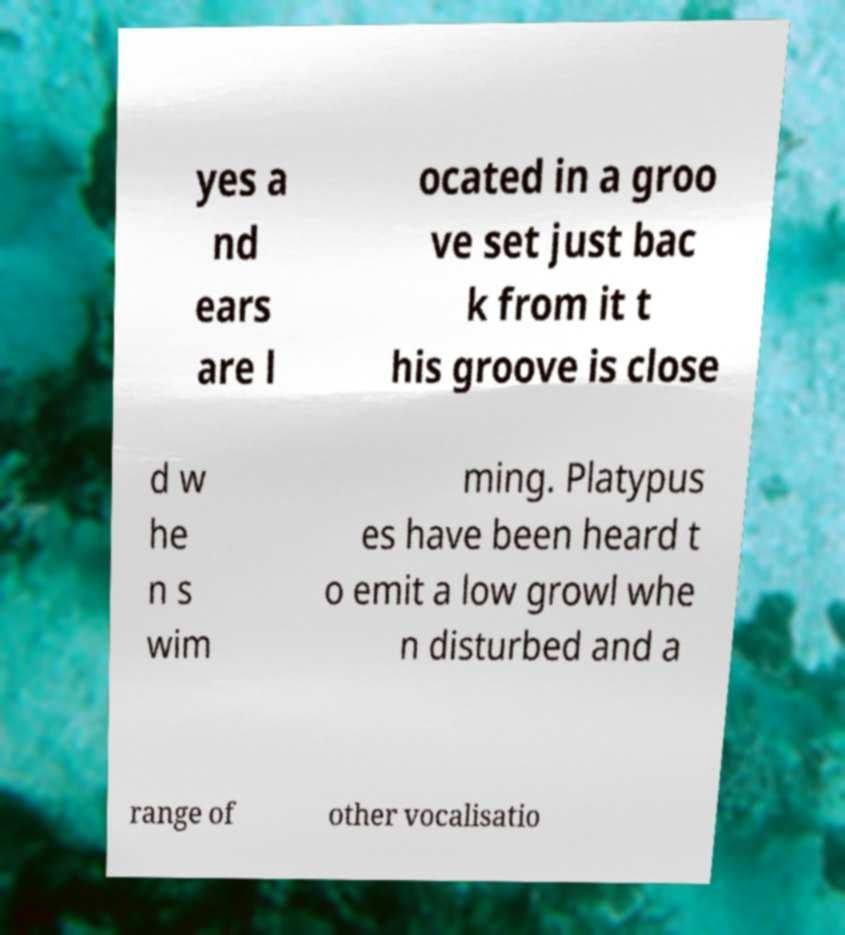There's text embedded in this image that I need extracted. Can you transcribe it verbatim? yes a nd ears are l ocated in a groo ve set just bac k from it t his groove is close d w he n s wim ming. Platypus es have been heard t o emit a low growl whe n disturbed and a range of other vocalisatio 